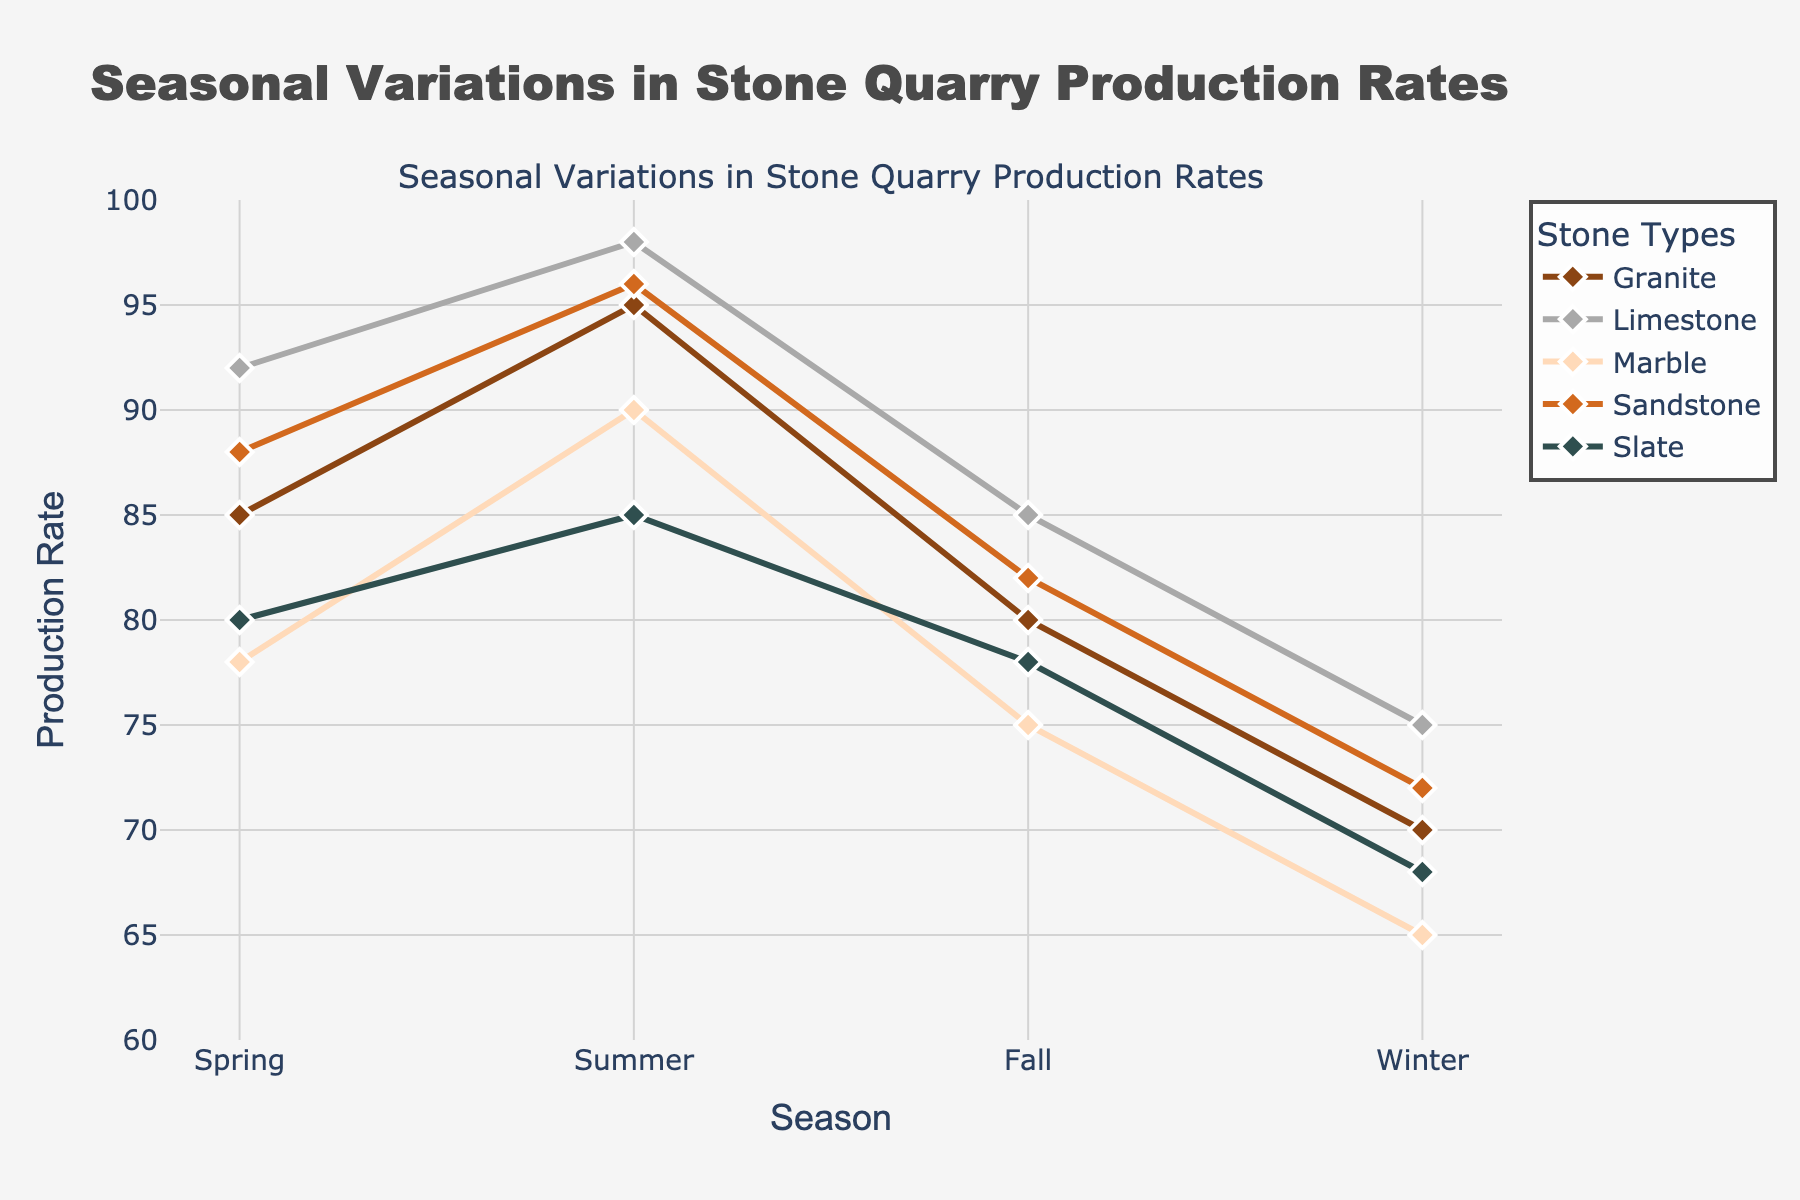How many stone types are shown in the plot? Count the number of different stone types in the legend.
Answer: 5 What season has the highest production rate for Granite? Look for the peak value in the Granite production line on the chart, and identify the corresponding season.
Answer: Summer Compare the production rates of Limestone and Marble in the Fall. Which is higher? Find the data points for Limestone and Marble in Fall and compare their values.
Answer: Limestone What is the average production rate for Sandstone across all seasons? Add the production rates of Sandstone for Spring, Summer, Fall, and Winter, then divide by the number of seasons (4). (88+96+82+72) = 338/4 = 84.5
Answer: 84.5 In which season is the difference between Slate and Granite production rates the smallest? Subtract the Granite production rate from the Slate production rate for each season and identify the smallest difference.
Answer: Spring Which stone type experiences the largest drop in production rate from Summer to Winter? Calculate the difference in production rates from Summer to Winter for each stone type and identify the largest drop.
Answer: Marble What is the total production rate of all stone types in Spring? Sum the production rates of Granite, Limestone, Marble, Sandstone, and Slate for Spring. (85+92+78+88+80) = 423
Answer: 423 During which season are all stone types' production rates the lowest? Identify the season where each stone type has the lowest production rate and confirm if it’s the same season for all stone types.
Answer: Winter Is the production rate of any stone type equal in any two seasons? Check if any stone type has the same production rate value in any two different seasons.
Answer: No What are the general trends observed for most stones from Winter to Summer? Look at the lines from Winter to Summer for the majority of stones and describe the observed trend.
Answer: Increasing 